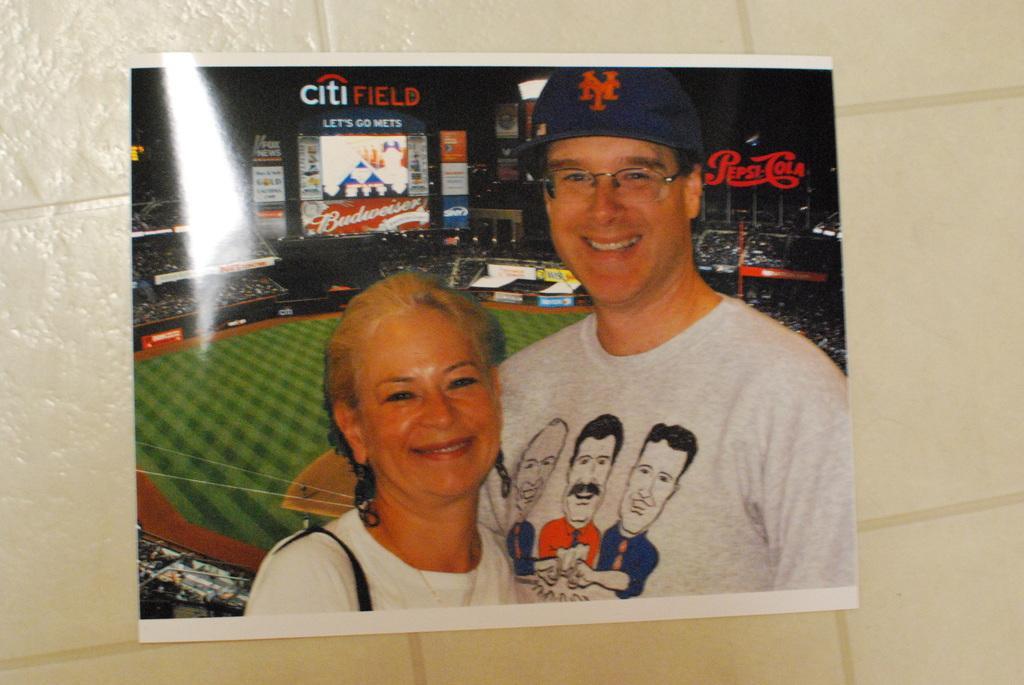Describe this image in one or two sentences. In this image, we can see a poster, on that poster there is a man and a woman, in the background we can see a playground. 